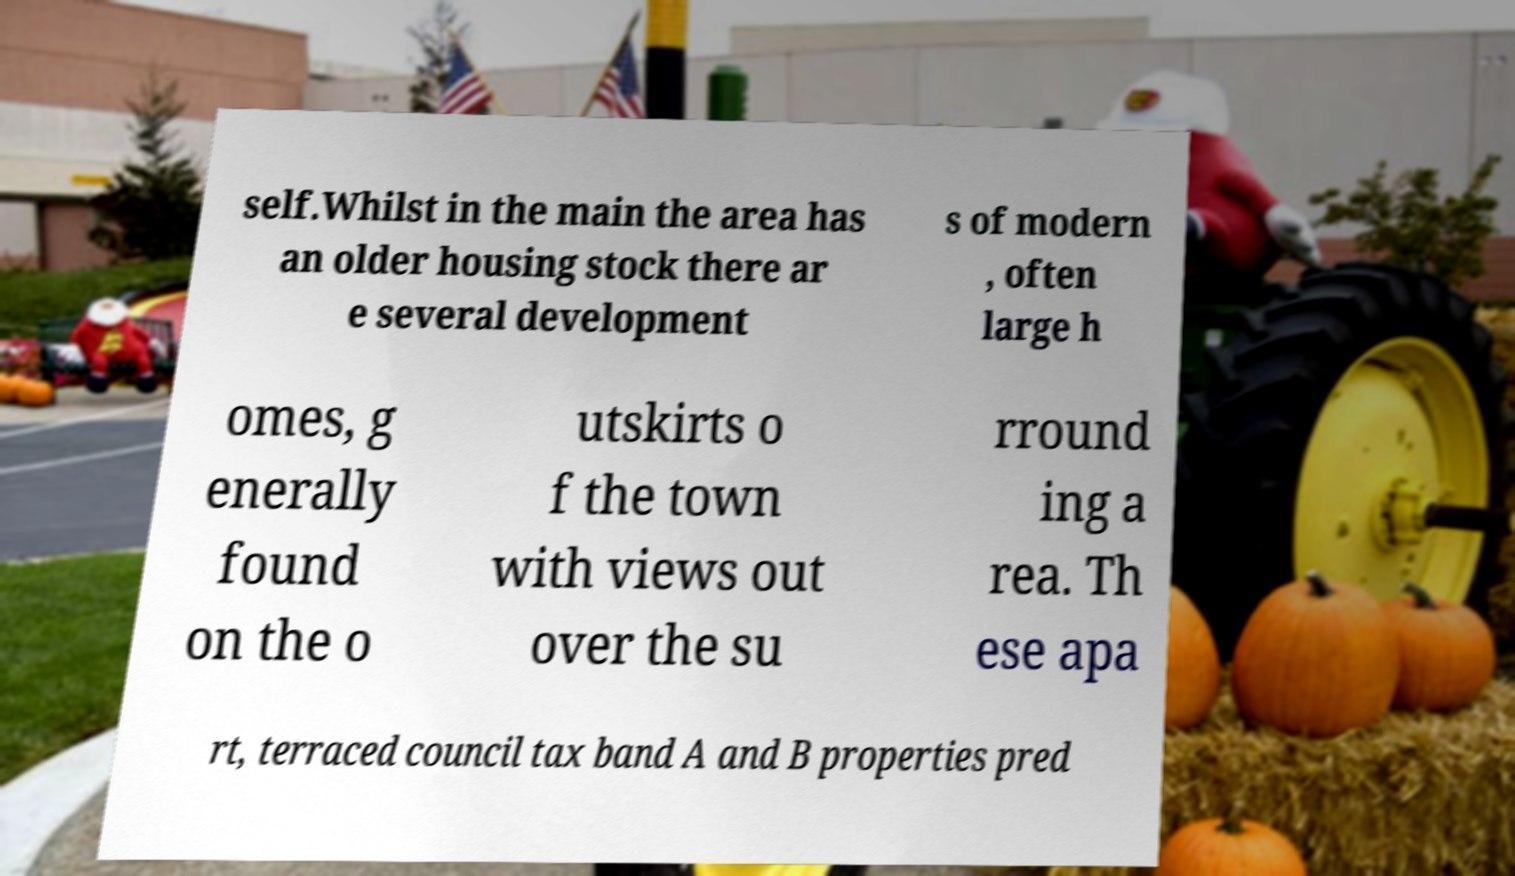For documentation purposes, I need the text within this image transcribed. Could you provide that? self.Whilst in the main the area has an older housing stock there ar e several development s of modern , often large h omes, g enerally found on the o utskirts o f the town with views out over the su rround ing a rea. Th ese apa rt, terraced council tax band A and B properties pred 